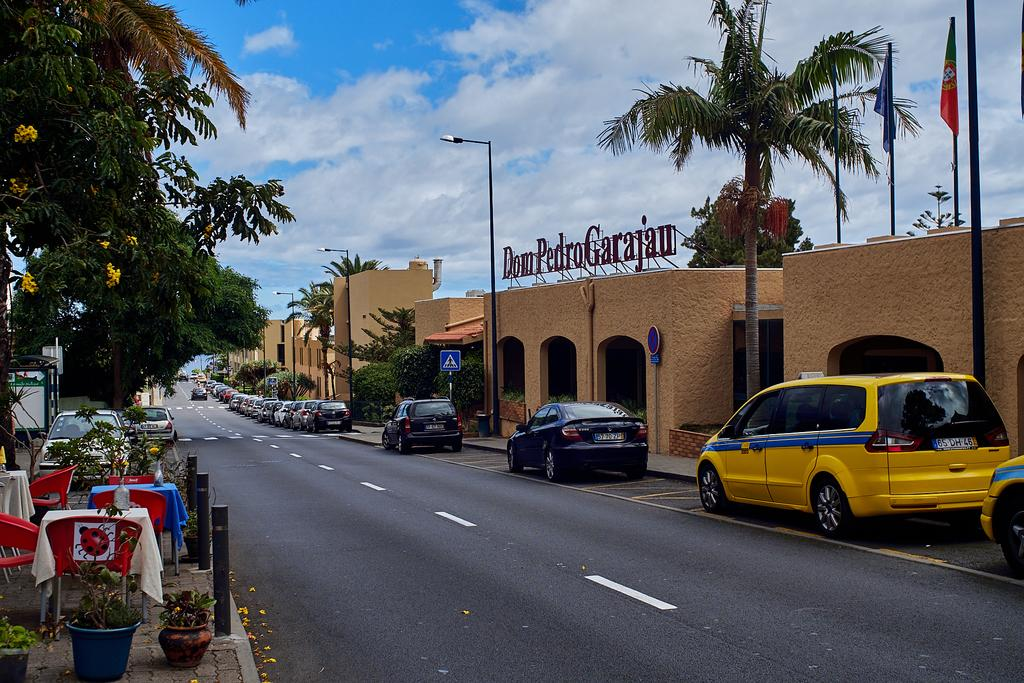<image>
Share a concise interpretation of the image provided. The building on the right of this street is called Dom Pedro Garajau. 